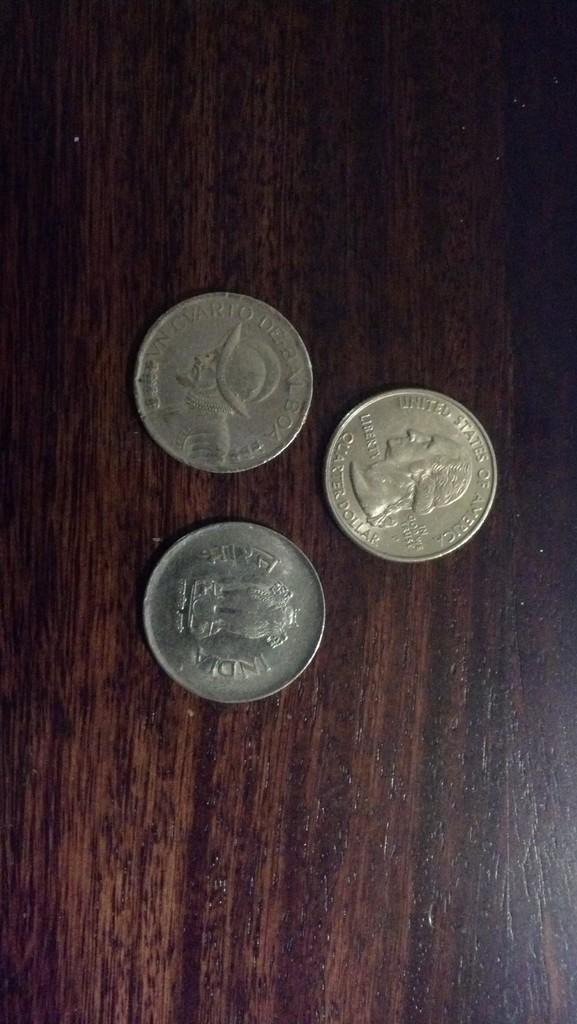<image>
Give a short and clear explanation of the subsequent image. Three coins on a table which one is a quarter and the other two are a foreign currency. 